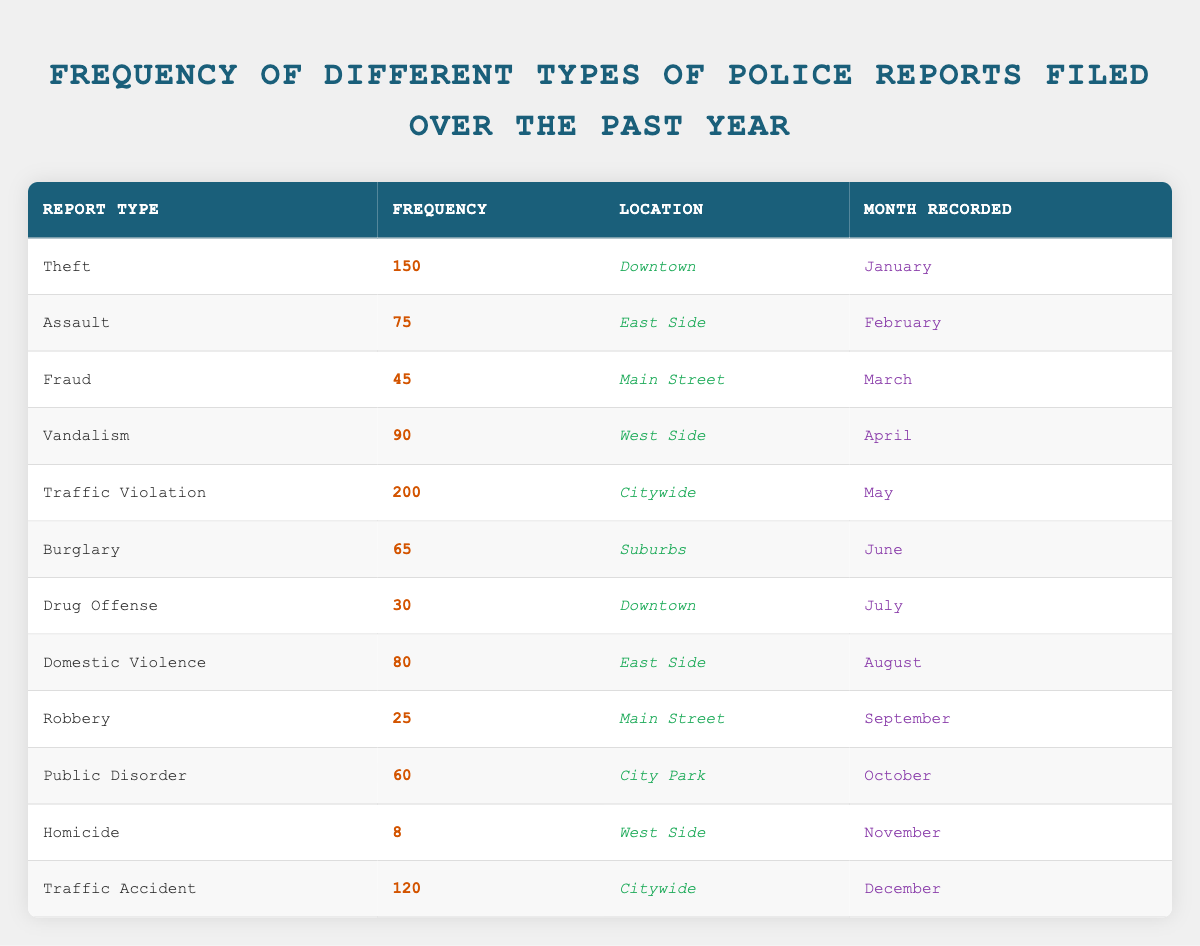What is the most frequently reported type of police report? The table shows that "Traffic Violation" has the highest frequency with 200 reports filed in May.
Answer: Traffic Violation In which month was the lowest number of police reports filed? The table indicates that the report type "Homicide" had the least frequency of 8, which was recorded in November.
Answer: November How many theft reports were filed compared to drug offenses? From the table, there were 150 theft reports and 30 drug offense reports. The difference is 150 - 30 = 120.
Answer: 120 Is the frequency of domestic violence reports greater than or equal to homicide reports? The table shows 80 domestic violence reports in August and 8 homicide reports in November. Since 80 is greater than 8, the statement is true.
Answer: Yes What is the average frequency of reports for Vandalism, Burglary, and Public Disorder? The frequencies for Vandalism (90), Burglary (65), and Public Disorder (60) can be summed: 90 + 65 + 60 = 215. Dividing by 3 gives an average of 215 / 3 = 71.67.
Answer: 71.67 Which locations recorded traffic-related offenses, and how many reports were filed in total? Traffic-related offenses include "Traffic Violation" (200, Citywide) and "Traffic Accident" (120, Citywide). Summing these gives 200 + 120 = 320.
Answer: 320 How many reports of robbery and domestic violence were combined? The table shows 25 robbery reports and 80 domestic violence reports. Adding these gives a total of 25 + 80 = 105.
Answer: 105 Was there a report type recorded in June that had a higher frequency than any report type recorded in October? The table shows that the report in June was "Burglary" with a frequency of 65, while "Public Disorder" in October had 60 reports. Since 65 > 60, the statement is true.
Answer: Yes 